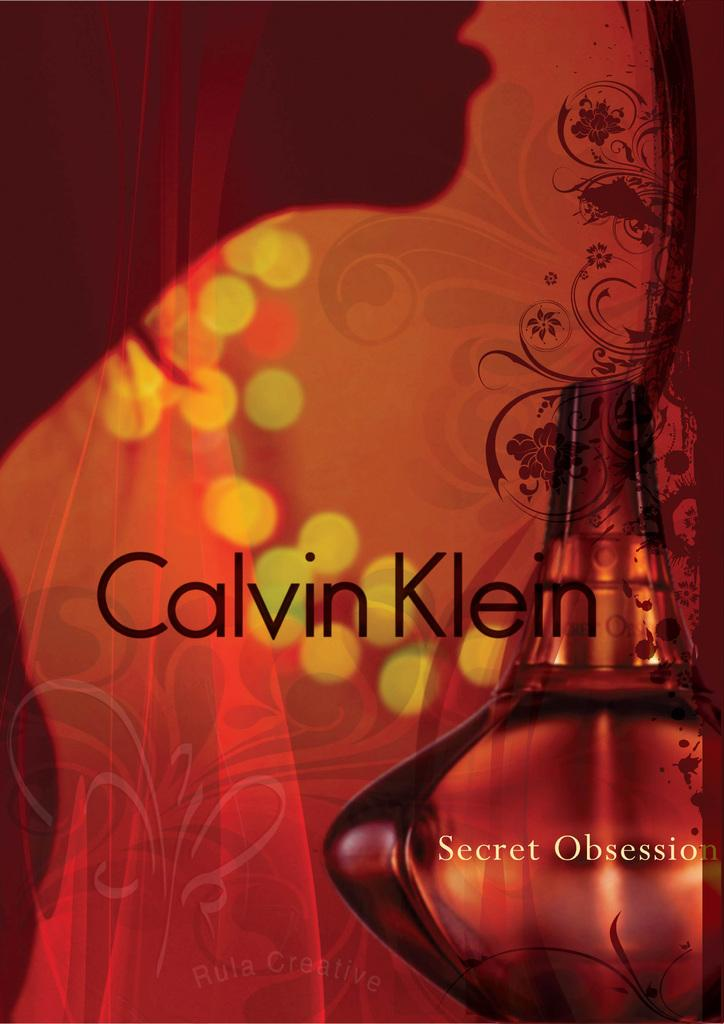Provide a one-sentence caption for the provided image. A perfume by Calvin Klein called Secret Obsession is shown with a red and orange background. 